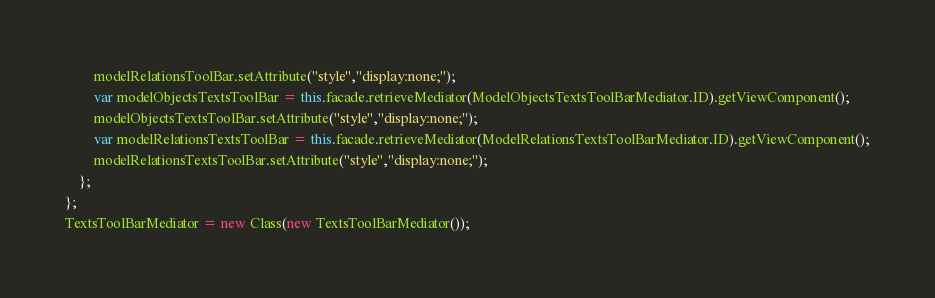Convert code to text. <code><loc_0><loc_0><loc_500><loc_500><_JavaScript_>		modelRelationsToolBar.setAttribute("style","display:none;");
		var modelObjectsTextsToolBar = this.facade.retrieveMediator(ModelObjectsTextsToolBarMediator.ID).getViewComponent();
		modelObjectsTextsToolBar.setAttribute("style","display:none;");
		var modelRelationsTextsToolBar = this.facade.retrieveMediator(ModelRelationsTextsToolBarMediator.ID).getViewComponent();
		modelRelationsTextsToolBar.setAttribute("style","display:none;");
	};
};
TextsToolBarMediator = new Class(new TextsToolBarMediator());
</code> 